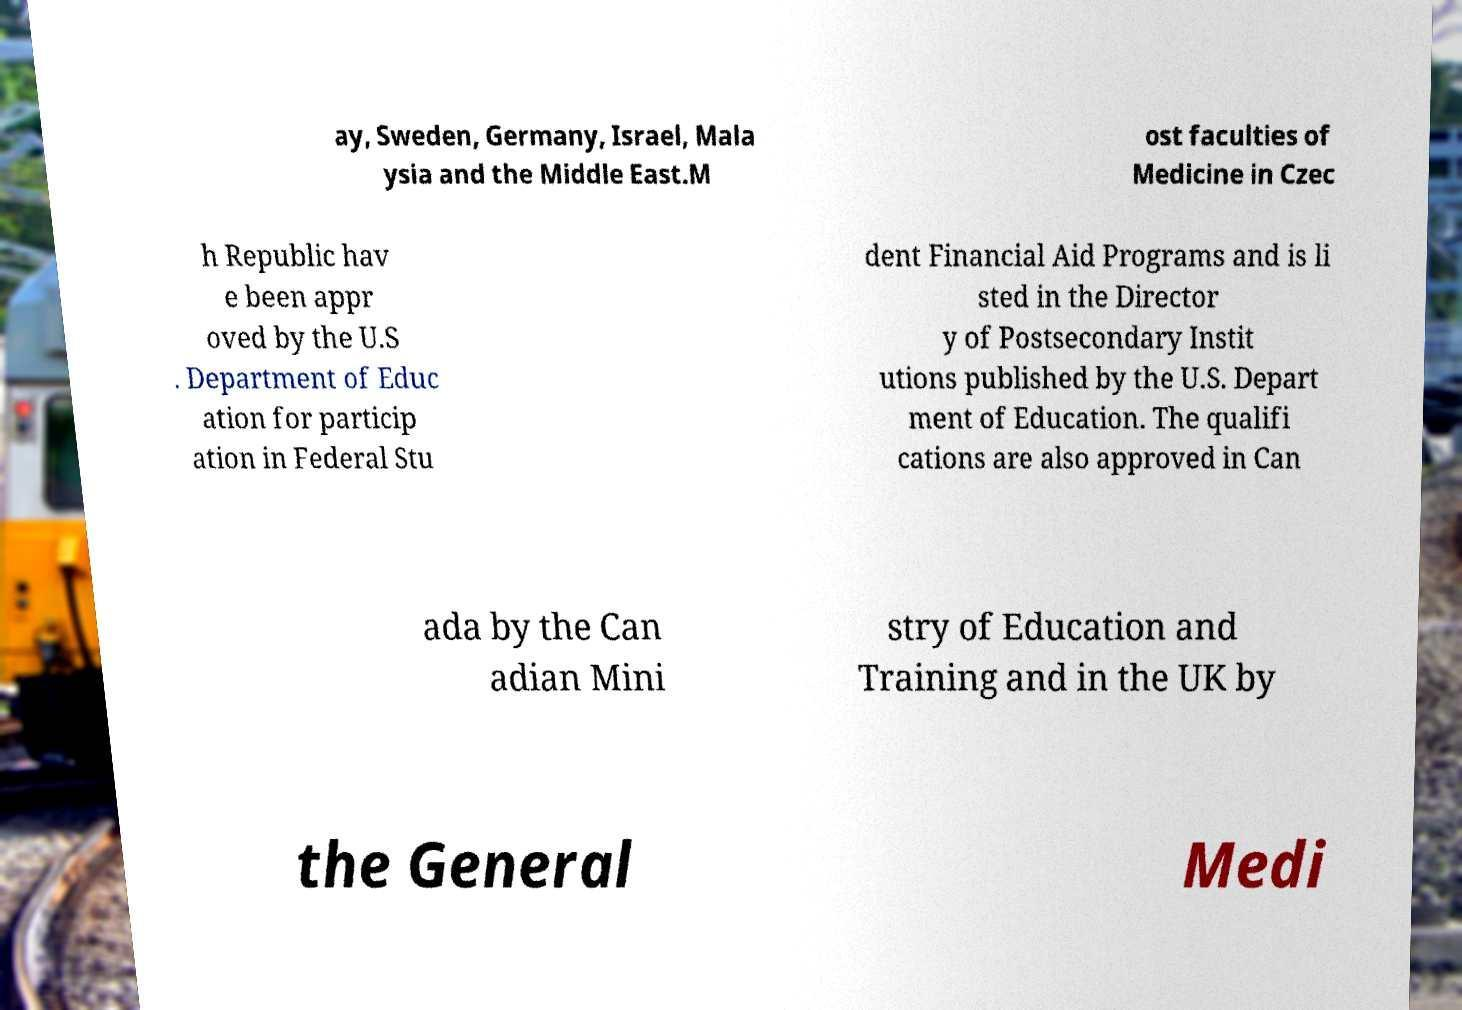I need the written content from this picture converted into text. Can you do that? ay, Sweden, Germany, Israel, Mala ysia and the Middle East.M ost faculties of Medicine in Czec h Republic hav e been appr oved by the U.S . Department of Educ ation for particip ation in Federal Stu dent Financial Aid Programs and is li sted in the Director y of Postsecondary Instit utions published by the U.S. Depart ment of Education. The qualifi cations are also approved in Can ada by the Can adian Mini stry of Education and Training and in the UK by the General Medi 